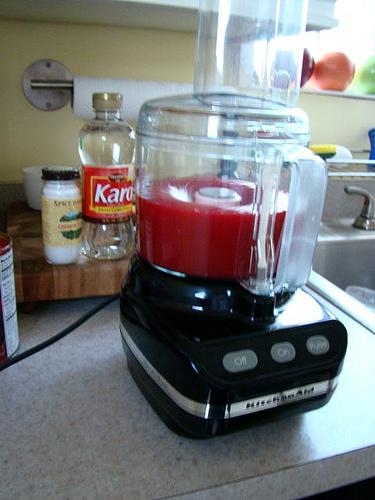Is the device made of stainless steel?
Short answer required. No. What is sitting in the window sill?
Short answer required. Fruit. What is in the bottle with the red label?
Write a very short answer. Syrup. What do you call the process the food is going through in the processor?
Short answer required. Blending. 